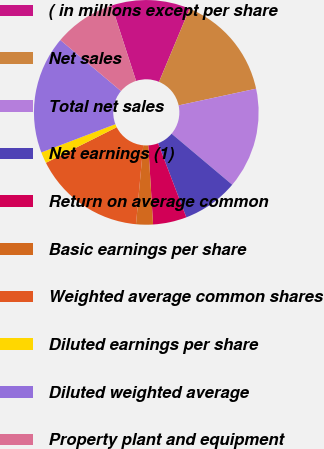Convert chart to OTSL. <chart><loc_0><loc_0><loc_500><loc_500><pie_chart><fcel>( in millions except per share<fcel>Net sales<fcel>Total net sales<fcel>Net earnings (1)<fcel>Return on average common<fcel>Basic earnings per share<fcel>Weighted average common shares<fcel>Diluted earnings per share<fcel>Diluted weighted average<fcel>Property plant and equipment<nl><fcel>11.29%<fcel>15.32%<fcel>14.52%<fcel>8.06%<fcel>4.84%<fcel>2.42%<fcel>16.13%<fcel>1.61%<fcel>16.94%<fcel>8.87%<nl></chart> 